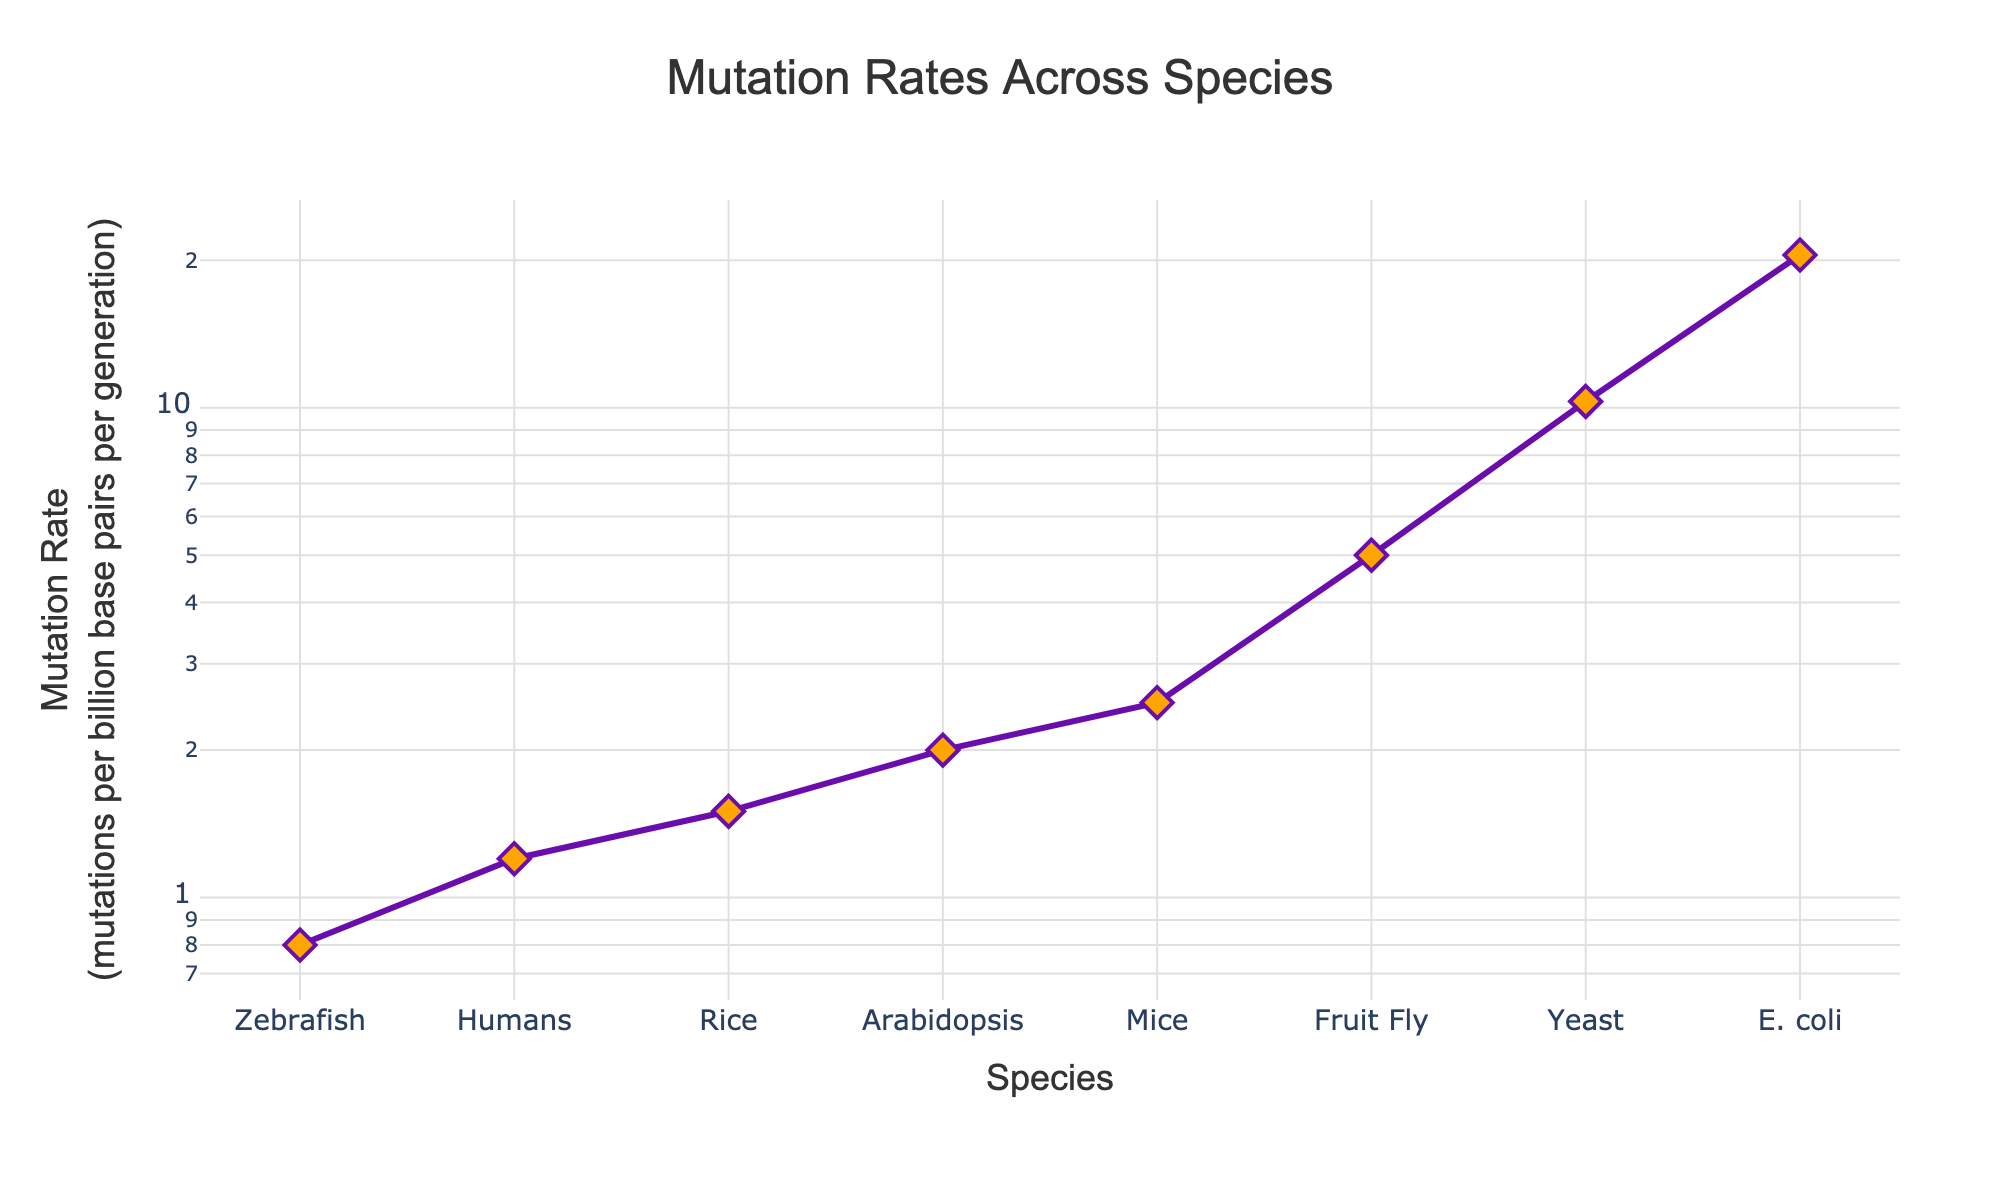What is the title of the plot? The title is located at the top of the figure, it reads "Mutation Rates Across Species".
Answer: Mutation Rates Across Species What is the y-axis title? The y-axis title is displayed vertically along the y-axis on the left side of the graph, it reads "Mutation Rate (mutations per billion base pairs per generation)".
Answer: Mutation Rate (mutations per billion base pairs per generation) Which species has the highest mutation rate? By looking at the plotted points and following the y-axis, the highest mutation rate is found at the topmost point, which corresponds to E. coli.
Answer: E. coli Which species has the lowest mutation rate? By looking at the plotted points and following the y-axis, the lowest mutation rate is found at the bottommost point, which corresponds to Zebrafish.
Answer: Zebrafish What is the difference in mutation rates between Humans and Mice? Find the y-values for Humans (1.2) and Mice (2.5). Subtract the mutation rate of Humans from that of Mice: 2.5 - 1.2 = 1.3.
Answer: 1.3 How many species have a mutation rate higher than 5.0? Identify the species with y-values greater than 5.0. These species are Yeast and E. coli, so there are 2 species.
Answer: 2 Which species have a mutation rate between 1 and 2? Locate the y-values between 1 and 2, corresponding to Humans (1.2), Rice (1.5), and Arabidopsis (2.0).
Answer: Humans, Rice, and Arabidopsis Based on the line plot, does the mutation rate trend upward or downward from Zebrafish to E. coli? Observing the lines connecting the points from Zebrafish to E. coli, the line trends upward, indicating an increase in mutation rate.
Answer: Upward What is the average mutation rate of all species shown? Sum the mutation rates of all species (1.2 + 2.5 + 0.8 + 5.0 + 10.3 + 20.5 + 1.5 + 2.0) = 43.8. Divide by the number of species (8): 43.8 / 8 = 5.475.
Answer: 5.475 Which species has a mutation rate closest to the average mutation rate? Calculate the average mutation rate (5.475). Compare each species' mutation rate to see which is closest. Arabidopsis (2.0) is the closest, with a difference of 3.475.
Answer: Arabidopsis 